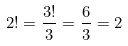<formula> <loc_0><loc_0><loc_500><loc_500>2 ! = \frac { 3 ! } { 3 } = \frac { 6 } { 3 } = 2</formula> 